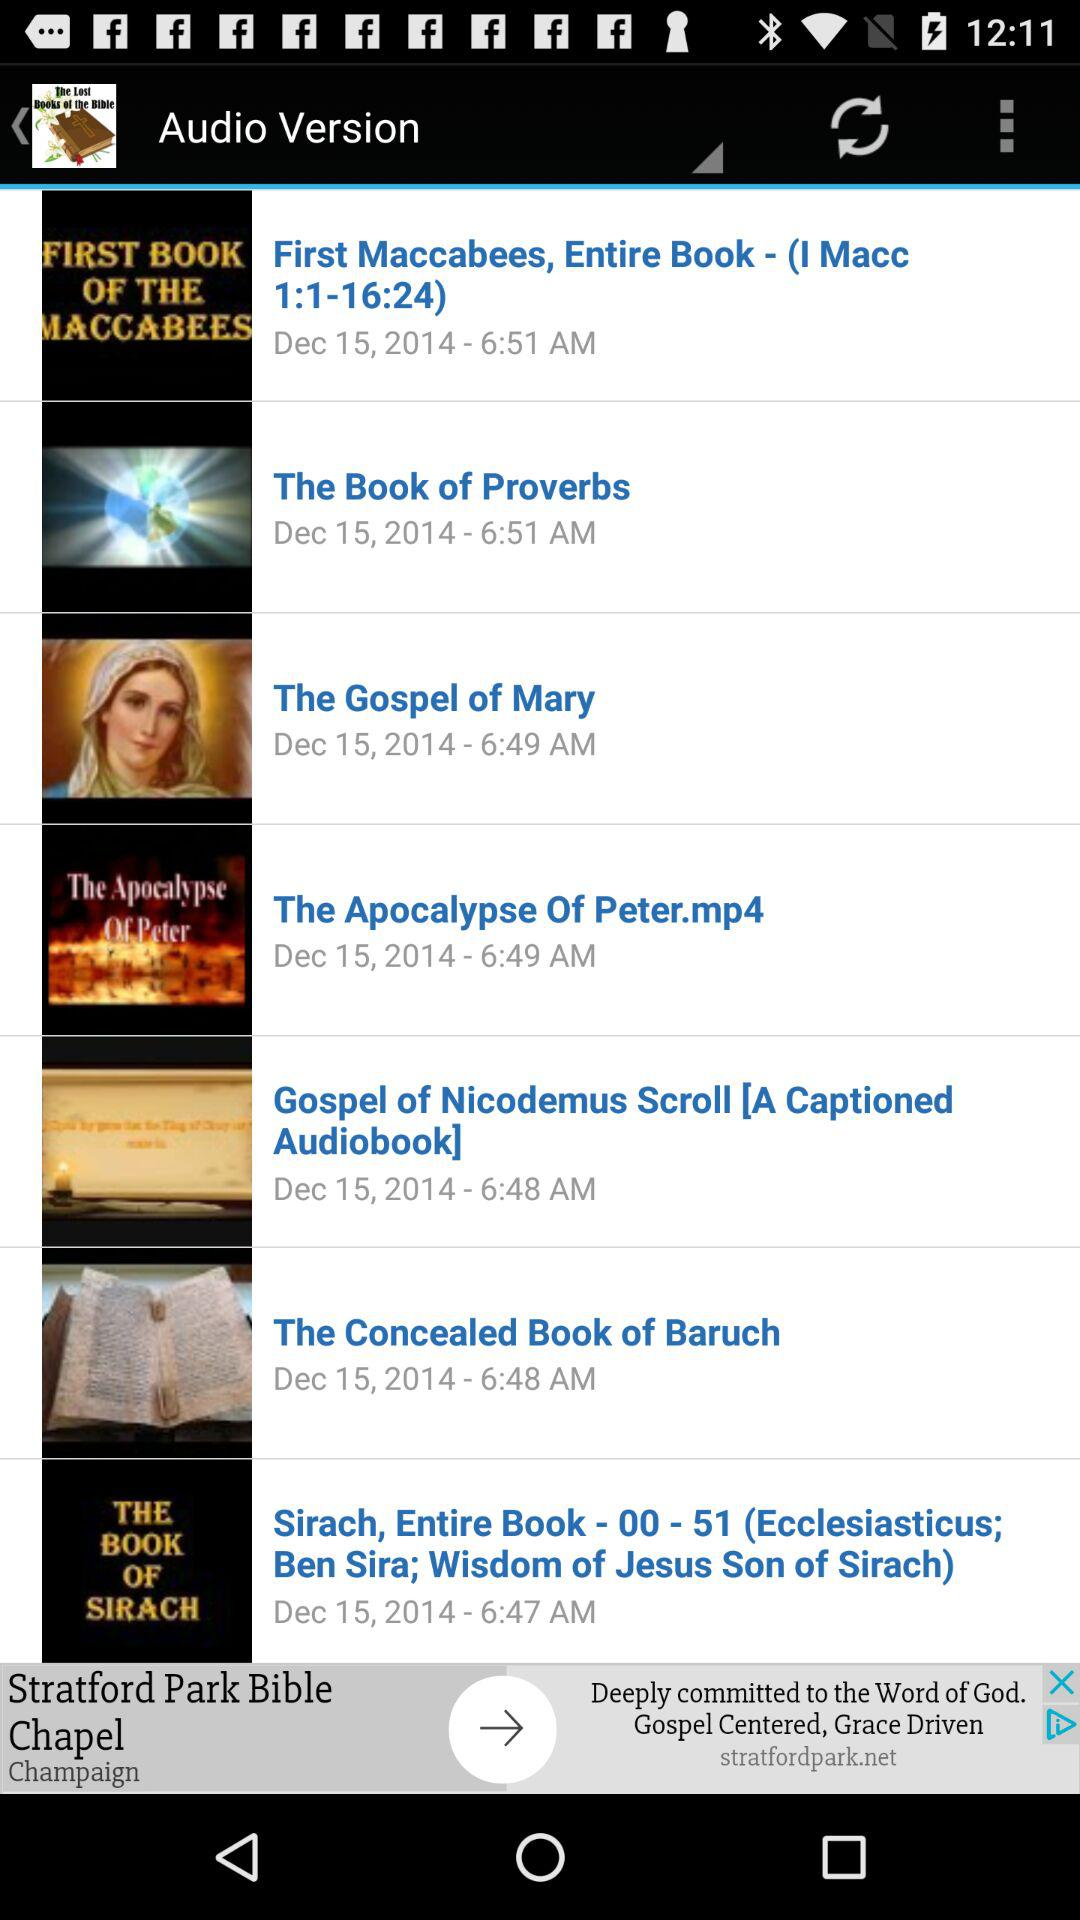What is the posted date of the "The Gospel of Mary"? The posted date is December 15, 2014. 